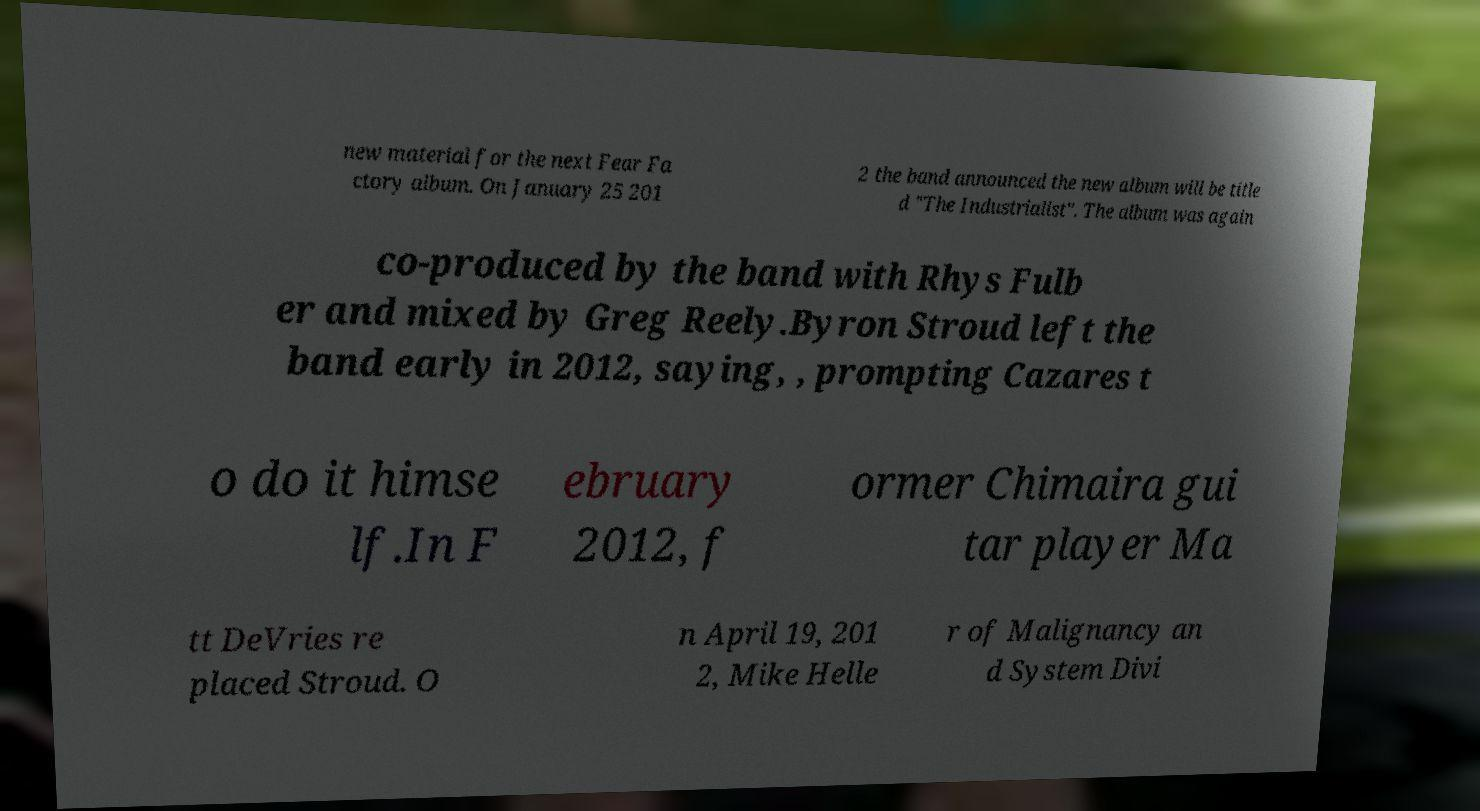Please identify and transcribe the text found in this image. new material for the next Fear Fa ctory album. On January 25 201 2 the band announced the new album will be title d "The Industrialist". The album was again co-produced by the band with Rhys Fulb er and mixed by Greg Reely.Byron Stroud left the band early in 2012, saying, , prompting Cazares t o do it himse lf.In F ebruary 2012, f ormer Chimaira gui tar player Ma tt DeVries re placed Stroud. O n April 19, 201 2, Mike Helle r of Malignancy an d System Divi 